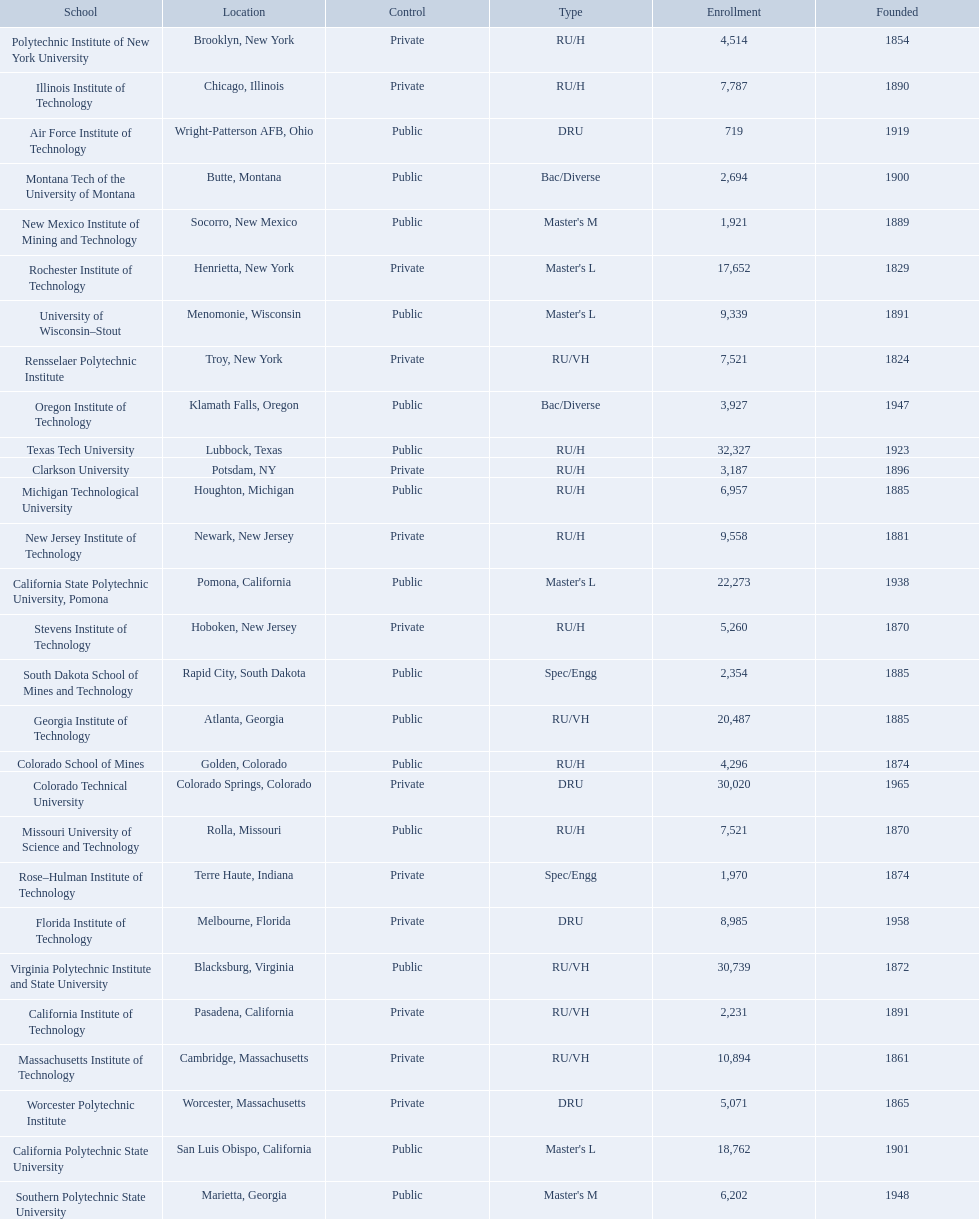What are all the schools? Air Force Institute of Technology, California Institute of Technology, California Polytechnic State University, California State Polytechnic University, Pomona, Clarkson University, Colorado School of Mines, Colorado Technical University, Florida Institute of Technology, Georgia Institute of Technology, Illinois Institute of Technology, Massachusetts Institute of Technology, Michigan Technological University, Missouri University of Science and Technology, Montana Tech of the University of Montana, New Jersey Institute of Technology, New Mexico Institute of Mining and Technology, Oregon Institute of Technology, Polytechnic Institute of New York University, Rensselaer Polytechnic Institute, Rochester Institute of Technology, Rose–Hulman Institute of Technology, South Dakota School of Mines and Technology, Southern Polytechnic State University, Stevens Institute of Technology, Texas Tech University, University of Wisconsin–Stout, Virginia Polytechnic Institute and State University, Worcester Polytechnic Institute. What is the enrollment of each school? 719, 2,231, 18,762, 22,273, 3,187, 4,296, 30,020, 8,985, 20,487, 7,787, 10,894, 6,957, 7,521, 2,694, 9,558, 1,921, 3,927, 4,514, 7,521, 17,652, 1,970, 2,354, 6,202, 5,260, 32,327, 9,339, 30,739, 5,071. And which school had the highest enrollment? Texas Tech University. 